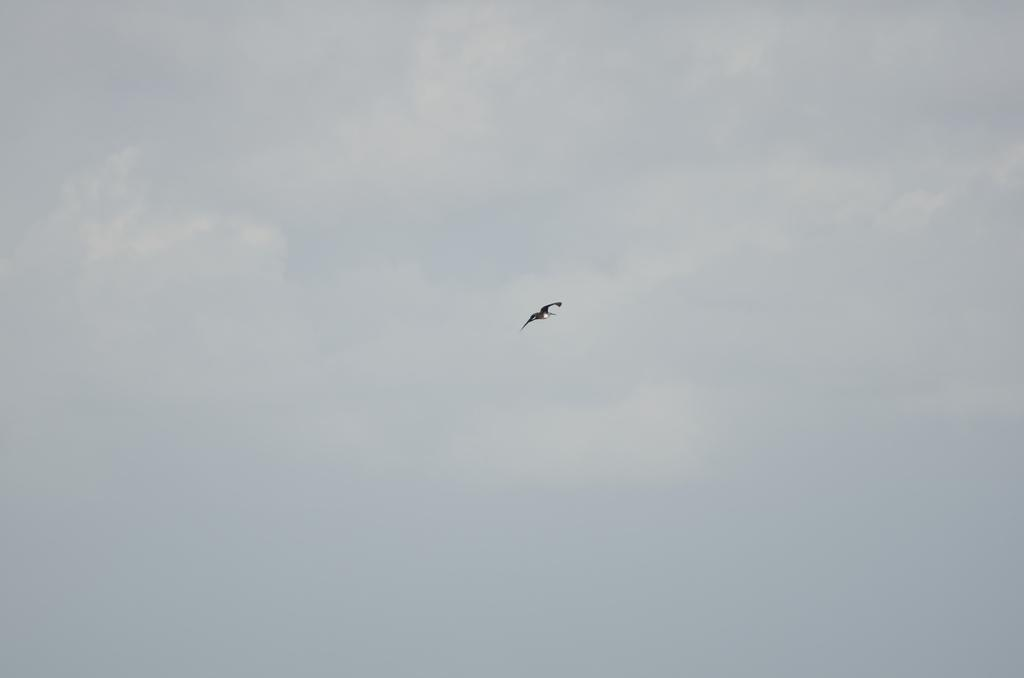What is the main subject of the picture? The main subject of the picture is a bird. Where is the bird located in the picture? The bird is in the middle of the picture. What can be seen in the background of the picture? The sky is visible in the background of the picture. What type of liquid can be seen dripping from the bird's beak in the image? There is no liquid dripping from the bird's beak in the image. How many pins are attached to the bird in the image? There are no pins present in the image, and the bird is not shown with any pins attached. 